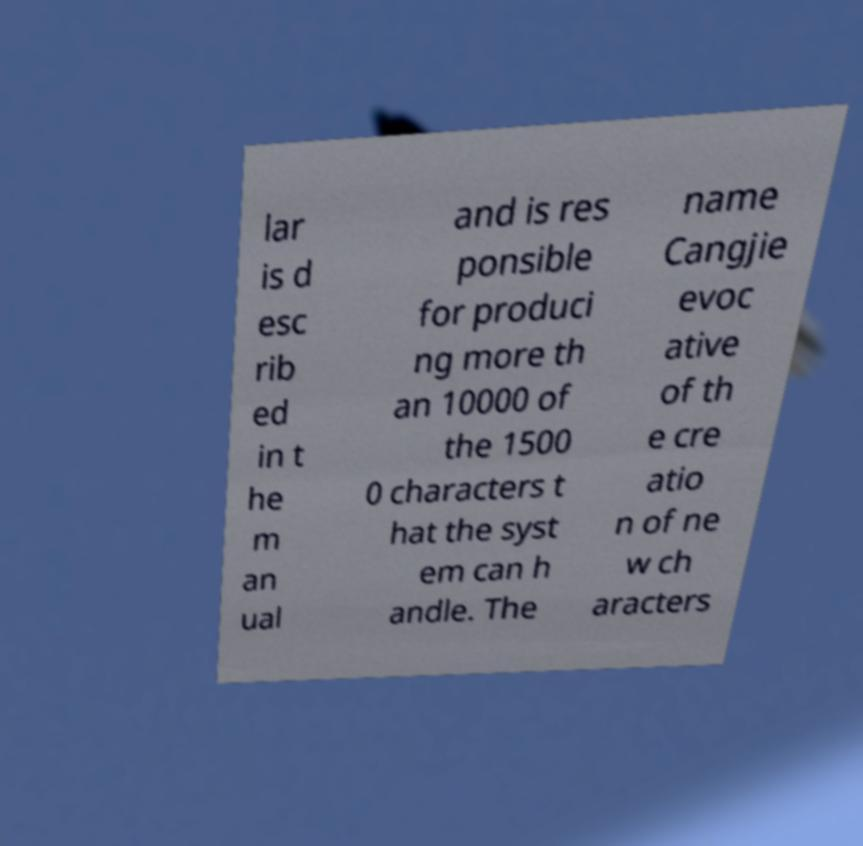Please read and relay the text visible in this image. What does it say? lar is d esc rib ed in t he m an ual and is res ponsible for produci ng more th an 10000 of the 1500 0 characters t hat the syst em can h andle. The name Cangjie evoc ative of th e cre atio n of ne w ch aracters 